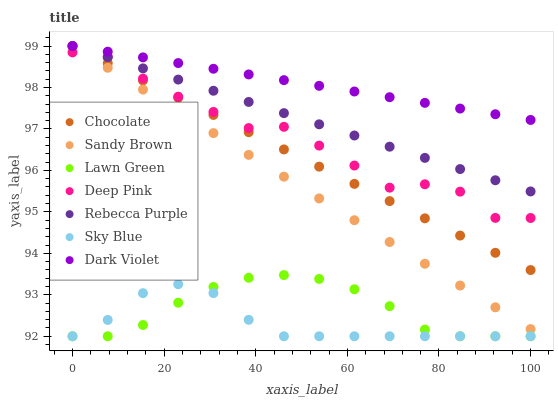Does Sky Blue have the minimum area under the curve?
Answer yes or no. Yes. Does Dark Violet have the maximum area under the curve?
Answer yes or no. Yes. Does Deep Pink have the minimum area under the curve?
Answer yes or no. No. Does Deep Pink have the maximum area under the curve?
Answer yes or no. No. Is Rebecca Purple the smoothest?
Answer yes or no. Yes. Is Deep Pink the roughest?
Answer yes or no. Yes. Is Dark Violet the smoothest?
Answer yes or no. No. Is Dark Violet the roughest?
Answer yes or no. No. Does Lawn Green have the lowest value?
Answer yes or no. Yes. Does Deep Pink have the lowest value?
Answer yes or no. No. Does Sandy Brown have the highest value?
Answer yes or no. Yes. Does Deep Pink have the highest value?
Answer yes or no. No. Is Sky Blue less than Deep Pink?
Answer yes or no. Yes. Is Rebecca Purple greater than Sky Blue?
Answer yes or no. Yes. Does Rebecca Purple intersect Sandy Brown?
Answer yes or no. Yes. Is Rebecca Purple less than Sandy Brown?
Answer yes or no. No. Is Rebecca Purple greater than Sandy Brown?
Answer yes or no. No. Does Sky Blue intersect Deep Pink?
Answer yes or no. No. 